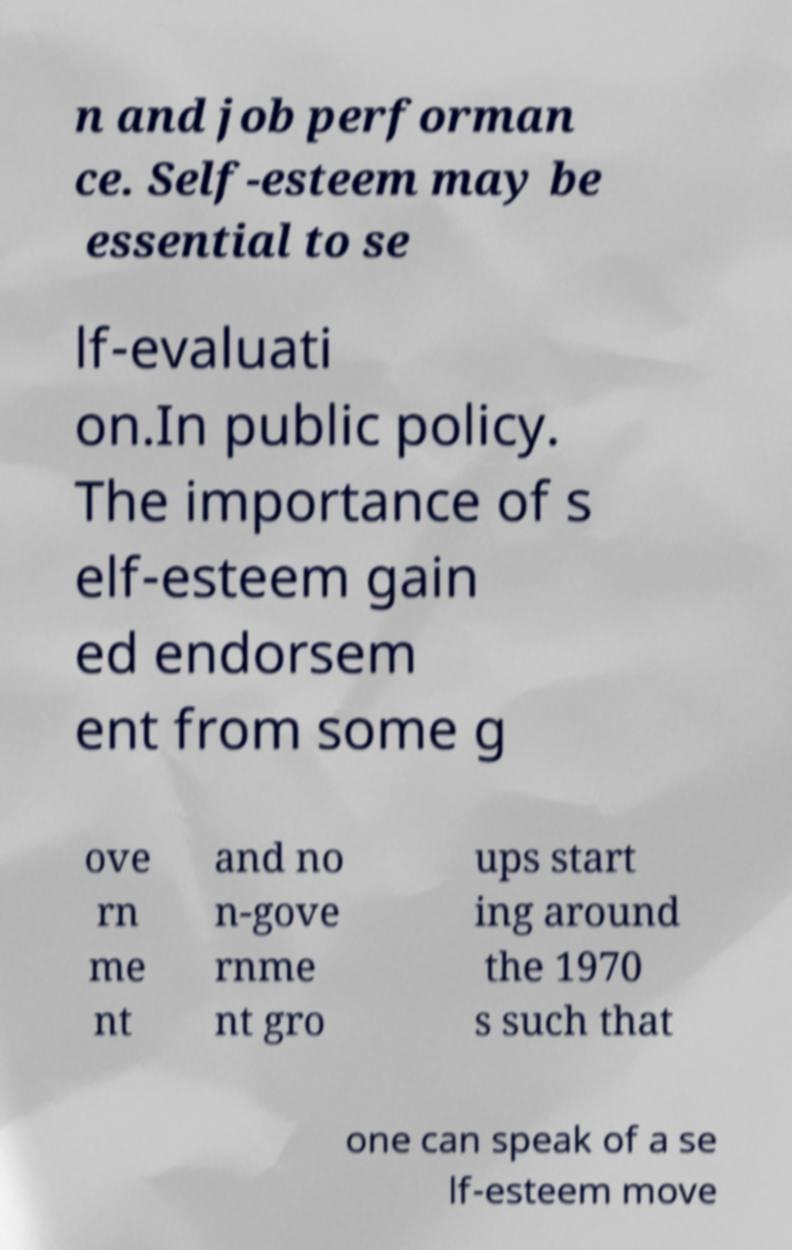I need the written content from this picture converted into text. Can you do that? n and job performan ce. Self-esteem may be essential to se lf-evaluati on.In public policy. The importance of s elf-esteem gain ed endorsem ent from some g ove rn me nt and no n-gove rnme nt gro ups start ing around the 1970 s such that one can speak of a se lf-esteem move 